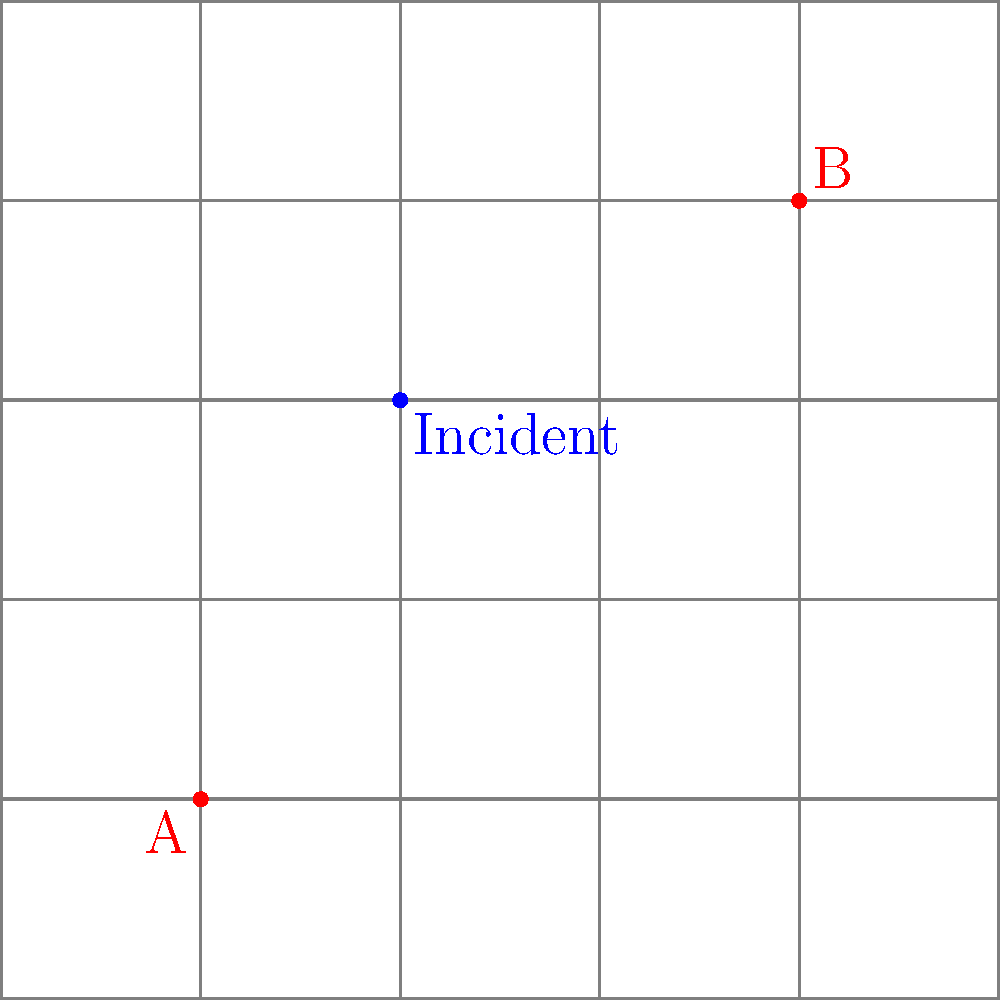In a 5x5 city grid, two police stations A and B are located at coordinates (1,1) and (4,4) respectively. An incident occurs at location (2,3). Assuming police cars can only move horizontally or vertically along the grid lines, what is the minimum total distance that needs to be traveled by a police car from either station to reach the incident location? To solve this problem, we need to calculate the Manhattan distance from each police station to the incident location and choose the shorter route. The Manhattan distance is the sum of the absolute differences of the coordinates.

Step 1: Calculate the distance from Station A (1,1) to the incident (2,3)
* Horizontal distance: $|2 - 1| = 1$
* Vertical distance: $|3 - 1| = 2$
* Total distance from A = $1 + 2 = 3$ units

Step 2: Calculate the distance from Station B (4,4) to the incident (2,3)
* Horizontal distance: $|2 - 4| = 2$
* Vertical distance: $|3 - 4| = 1$
* Total distance from B = $2 + 1 = 3$ units

Step 3: Compare the distances
Both stations A and B are 3 units away from the incident location.

Therefore, the minimum total distance that needs to be traveled by a police car from either station to reach the incident location is 3 units.
Answer: 3 units 